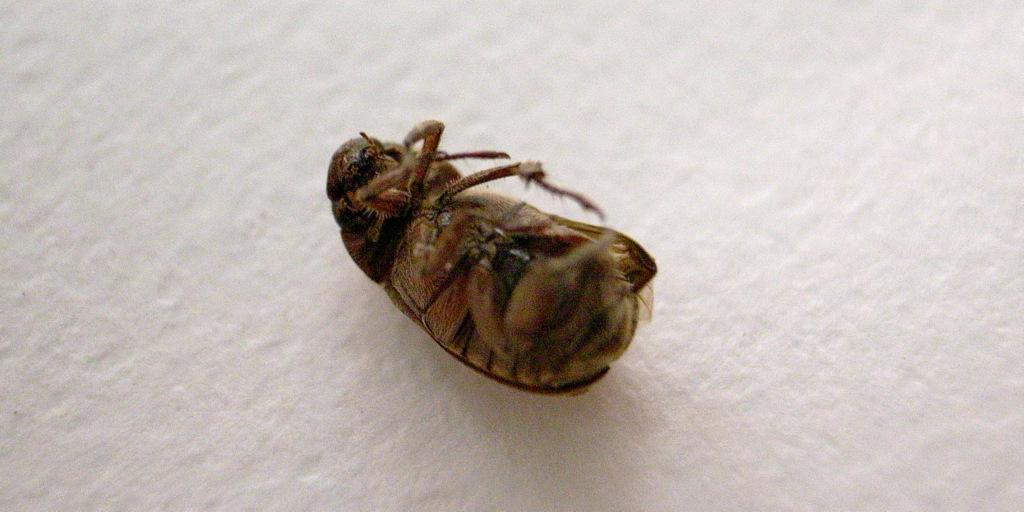What is the main subject of the image? The main subject of the image is a cockroach. What is the color of the background in the image? The background of the image is white. What type of celery is the secretary eating in the image? There is no secretary or celery present in the image, as it features a cockroach and a white background. 